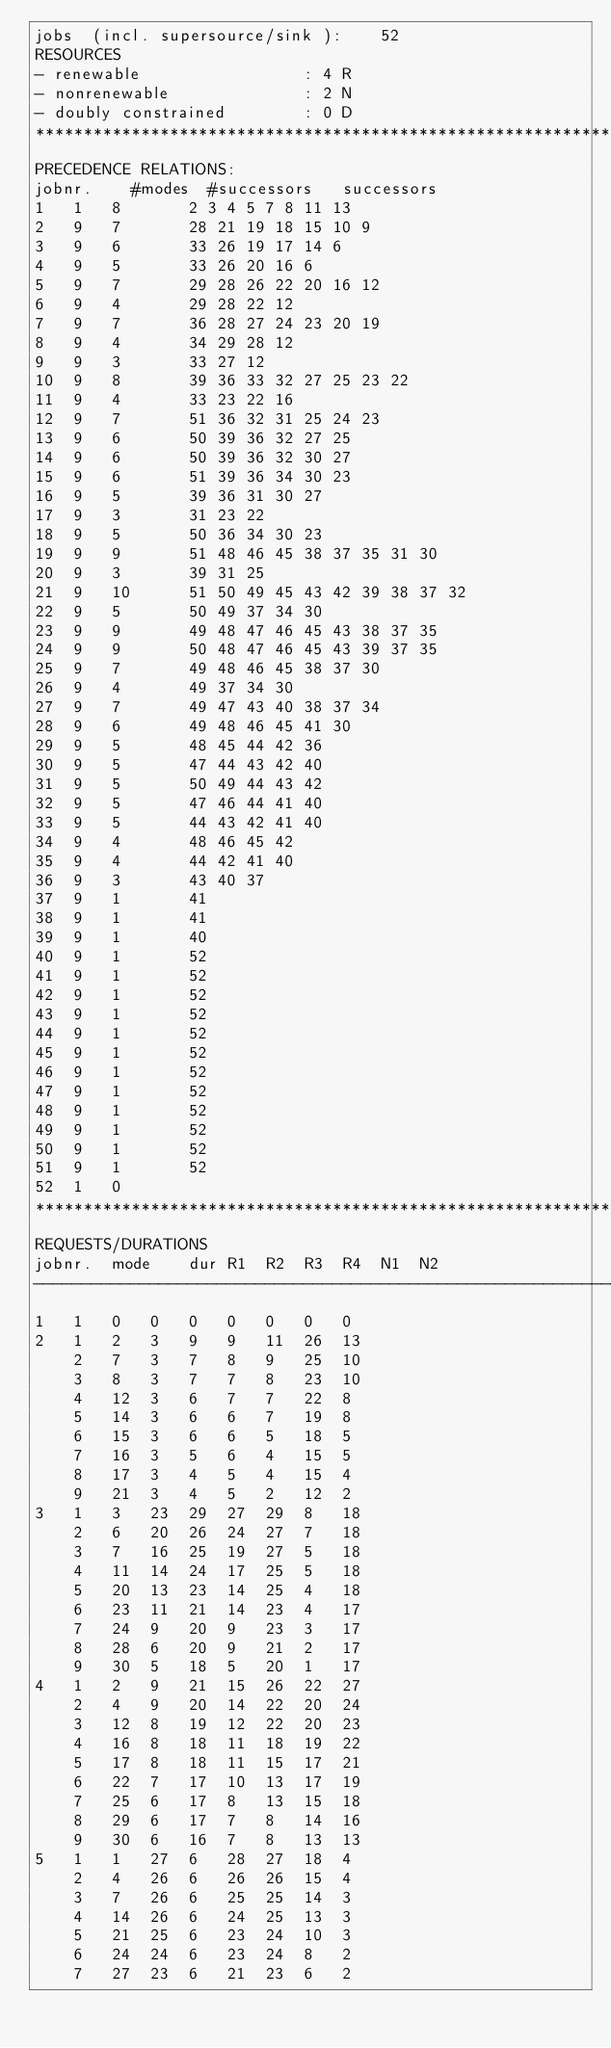<code> <loc_0><loc_0><loc_500><loc_500><_ObjectiveC_>jobs  (incl. supersource/sink ):	52
RESOURCES
- renewable                 : 4 R
- nonrenewable              : 2 N
- doubly constrained        : 0 D
************************************************************************
PRECEDENCE RELATIONS:
jobnr.    #modes  #successors   successors
1	1	8		2 3 4 5 7 8 11 13 
2	9	7		28 21 19 18 15 10 9 
3	9	6		33 26 19 17 14 6 
4	9	5		33 26 20 16 6 
5	9	7		29 28 26 22 20 16 12 
6	9	4		29 28 22 12 
7	9	7		36 28 27 24 23 20 19 
8	9	4		34 29 28 12 
9	9	3		33 27 12 
10	9	8		39 36 33 32 27 25 23 22 
11	9	4		33 23 22 16 
12	9	7		51 36 32 31 25 24 23 
13	9	6		50 39 36 32 27 25 
14	9	6		50 39 36 32 30 27 
15	9	6		51 39 36 34 30 23 
16	9	5		39 36 31 30 27 
17	9	3		31 23 22 
18	9	5		50 36 34 30 23 
19	9	9		51 48 46 45 38 37 35 31 30 
20	9	3		39 31 25 
21	9	10		51 50 49 45 43 42 39 38 37 32 
22	9	5		50 49 37 34 30 
23	9	9		49 48 47 46 45 43 38 37 35 
24	9	9		50 48 47 46 45 43 39 37 35 
25	9	7		49 48 46 45 38 37 30 
26	9	4		49 37 34 30 
27	9	7		49 47 43 40 38 37 34 
28	9	6		49 48 46 45 41 30 
29	9	5		48 45 44 42 36 
30	9	5		47 44 43 42 40 
31	9	5		50 49 44 43 42 
32	9	5		47 46 44 41 40 
33	9	5		44 43 42 41 40 
34	9	4		48 46 45 42 
35	9	4		44 42 41 40 
36	9	3		43 40 37 
37	9	1		41 
38	9	1		41 
39	9	1		40 
40	9	1		52 
41	9	1		52 
42	9	1		52 
43	9	1		52 
44	9	1		52 
45	9	1		52 
46	9	1		52 
47	9	1		52 
48	9	1		52 
49	9	1		52 
50	9	1		52 
51	9	1		52 
52	1	0		
************************************************************************
REQUESTS/DURATIONS
jobnr.	mode	dur	R1	R2	R3	R4	N1	N2	
------------------------------------------------------------------------
1	1	0	0	0	0	0	0	0	
2	1	2	3	9	9	11	26	13	
	2	7	3	7	8	9	25	10	
	3	8	3	7	7	8	23	10	
	4	12	3	6	7	7	22	8	
	5	14	3	6	6	7	19	8	
	6	15	3	6	6	5	18	5	
	7	16	3	5	6	4	15	5	
	8	17	3	4	5	4	15	4	
	9	21	3	4	5	2	12	2	
3	1	3	23	29	27	29	8	18	
	2	6	20	26	24	27	7	18	
	3	7	16	25	19	27	5	18	
	4	11	14	24	17	25	5	18	
	5	20	13	23	14	25	4	18	
	6	23	11	21	14	23	4	17	
	7	24	9	20	9	23	3	17	
	8	28	6	20	9	21	2	17	
	9	30	5	18	5	20	1	17	
4	1	2	9	21	15	26	22	27	
	2	4	9	20	14	22	20	24	
	3	12	8	19	12	22	20	23	
	4	16	8	18	11	18	19	22	
	5	17	8	18	11	15	17	21	
	6	22	7	17	10	13	17	19	
	7	25	6	17	8	13	15	18	
	8	29	6	17	7	8	14	16	
	9	30	6	16	7	8	13	13	
5	1	1	27	6	28	27	18	4	
	2	4	26	6	26	26	15	4	
	3	7	26	6	25	25	14	3	
	4	14	26	6	24	25	13	3	
	5	21	25	6	23	24	10	3	
	6	24	24	6	23	24	8	2	
	7	27	23	6	21	23	6	2	</code> 